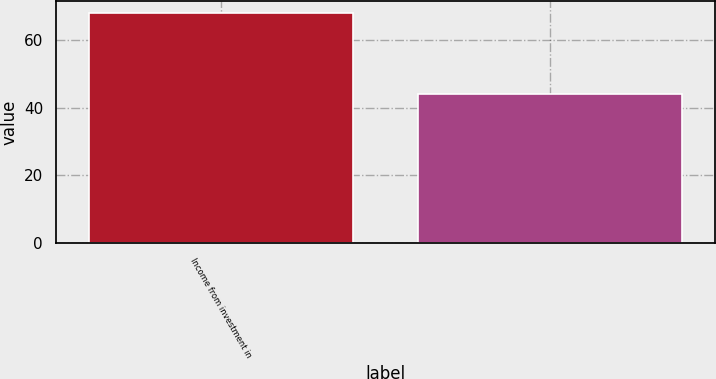Convert chart. <chart><loc_0><loc_0><loc_500><loc_500><bar_chart><fcel>Income from investment in<fcel>Unnamed: 1<nl><fcel>68<fcel>44<nl></chart> 